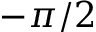<formula> <loc_0><loc_0><loc_500><loc_500>- \pi / 2</formula> 